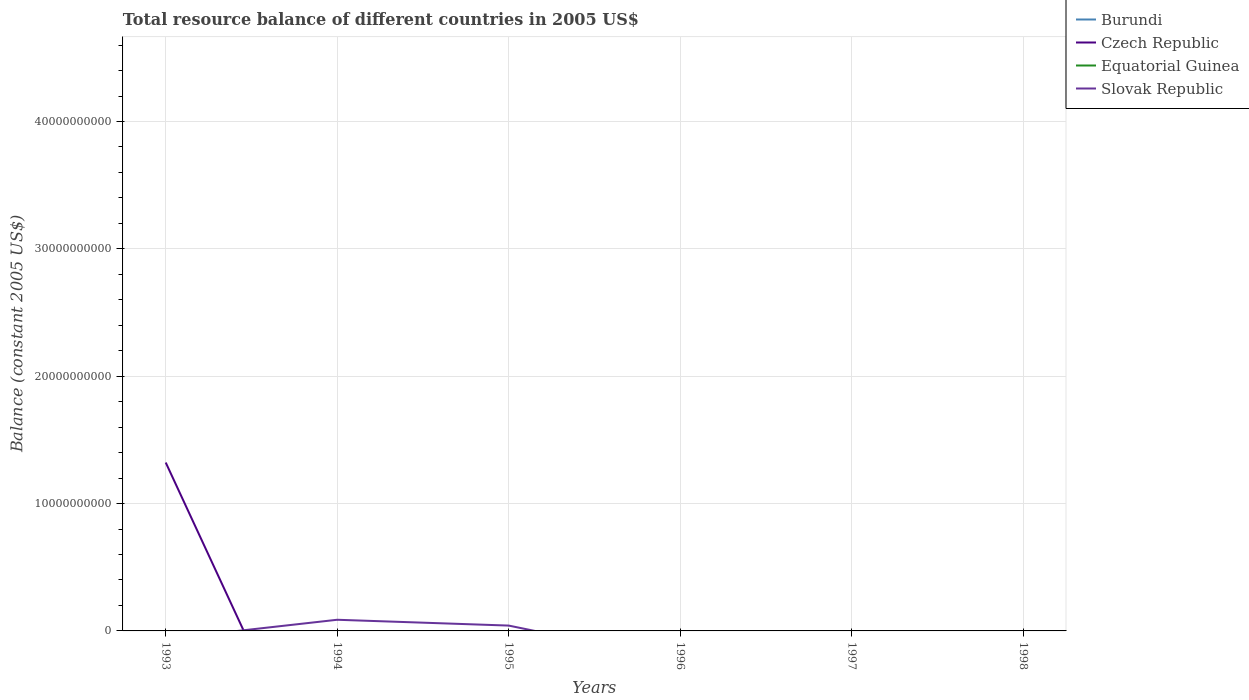Is the number of lines equal to the number of legend labels?
Keep it short and to the point. No. What is the difference between the highest and the second highest total resource balance in Czech Republic?
Your response must be concise. 1.32e+1. How many lines are there?
Your response must be concise. 2. How many years are there in the graph?
Make the answer very short. 6. What is the difference between two consecutive major ticks on the Y-axis?
Your answer should be very brief. 1.00e+1. Are the values on the major ticks of Y-axis written in scientific E-notation?
Give a very brief answer. No. Does the graph contain any zero values?
Provide a succinct answer. Yes. Where does the legend appear in the graph?
Your answer should be compact. Top right. How are the legend labels stacked?
Keep it short and to the point. Vertical. What is the title of the graph?
Your answer should be very brief. Total resource balance of different countries in 2005 US$. What is the label or title of the Y-axis?
Make the answer very short. Balance (constant 2005 US$). What is the Balance (constant 2005 US$) of Czech Republic in 1993?
Your answer should be compact. 1.32e+1. What is the Balance (constant 2005 US$) in Equatorial Guinea in 1993?
Offer a terse response. 0. What is the Balance (constant 2005 US$) in Equatorial Guinea in 1994?
Your answer should be compact. 0. What is the Balance (constant 2005 US$) in Slovak Republic in 1994?
Provide a short and direct response. 8.76e+08. What is the Balance (constant 2005 US$) in Burundi in 1995?
Your answer should be compact. 0. What is the Balance (constant 2005 US$) of Slovak Republic in 1995?
Offer a terse response. 4.20e+08. What is the Balance (constant 2005 US$) of Burundi in 1996?
Make the answer very short. 0. What is the Balance (constant 2005 US$) of Slovak Republic in 1996?
Your answer should be compact. 0. What is the Balance (constant 2005 US$) of Czech Republic in 1997?
Offer a very short reply. 0. What is the Balance (constant 2005 US$) in Equatorial Guinea in 1997?
Provide a succinct answer. 0. What is the Balance (constant 2005 US$) in Burundi in 1998?
Give a very brief answer. 0. What is the Balance (constant 2005 US$) in Equatorial Guinea in 1998?
Provide a short and direct response. 0. What is the Balance (constant 2005 US$) of Slovak Republic in 1998?
Your answer should be compact. 0. Across all years, what is the maximum Balance (constant 2005 US$) in Czech Republic?
Provide a succinct answer. 1.32e+1. Across all years, what is the maximum Balance (constant 2005 US$) of Slovak Republic?
Your answer should be very brief. 8.76e+08. What is the total Balance (constant 2005 US$) of Burundi in the graph?
Your response must be concise. 0. What is the total Balance (constant 2005 US$) in Czech Republic in the graph?
Offer a terse response. 1.32e+1. What is the total Balance (constant 2005 US$) in Slovak Republic in the graph?
Ensure brevity in your answer.  1.30e+09. What is the difference between the Balance (constant 2005 US$) of Slovak Republic in 1994 and that in 1995?
Your answer should be compact. 4.57e+08. What is the difference between the Balance (constant 2005 US$) in Czech Republic in 1993 and the Balance (constant 2005 US$) in Slovak Republic in 1994?
Give a very brief answer. 1.23e+1. What is the difference between the Balance (constant 2005 US$) of Czech Republic in 1993 and the Balance (constant 2005 US$) of Slovak Republic in 1995?
Your answer should be compact. 1.28e+1. What is the average Balance (constant 2005 US$) of Czech Republic per year?
Give a very brief answer. 2.20e+09. What is the average Balance (constant 2005 US$) in Equatorial Guinea per year?
Provide a short and direct response. 0. What is the average Balance (constant 2005 US$) of Slovak Republic per year?
Make the answer very short. 2.16e+08. What is the ratio of the Balance (constant 2005 US$) of Slovak Republic in 1994 to that in 1995?
Offer a terse response. 2.09. What is the difference between the highest and the lowest Balance (constant 2005 US$) in Czech Republic?
Your answer should be compact. 1.32e+1. What is the difference between the highest and the lowest Balance (constant 2005 US$) of Slovak Republic?
Keep it short and to the point. 8.76e+08. 